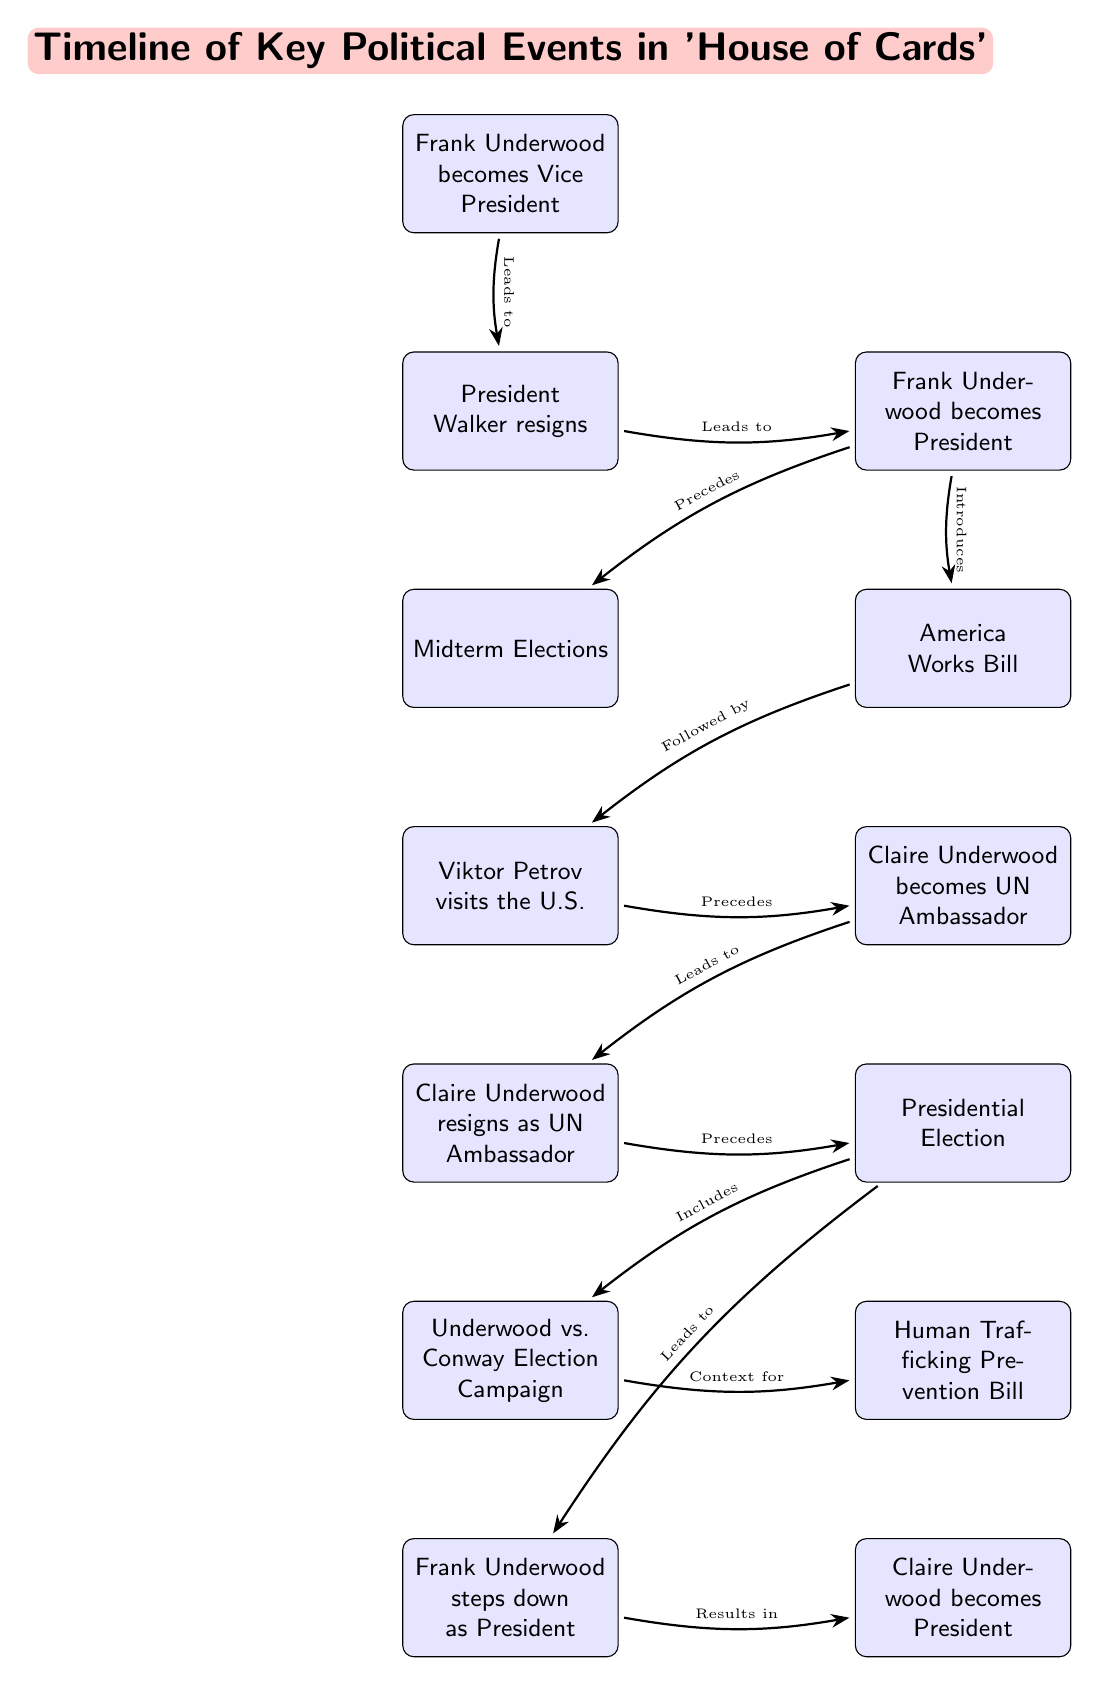What year did Frank Underwood become Vice President? The diagram states that Frank Underwood became Vice President in the year listed next to his event node, which is 2013.
Answer: 2013 What is the event that immediately precedes the Presidential Election? The diagram shows that Claire Underwood's resignation as UN Ambassador directly precedes the Presidential Election event in the timeline.
Answer: Claire Underwood resigns as UN Ambassador How many significant political events are mentioned in the diagram? By counting the individual event nodes in the diagram, there are nine significant political events listed.
Answer: 9 What event follows the introduction of the America Works Bill? The diagram indicates that the visit by Viktor Petrov follows the introduction of the America Works Bill in the timeline.
Answer: Viktor Petrov visits the U.S Which character becomes President after Frank Underwood steps down? The diagram illustrates that Claire Underwood becomes President after Frank Underwood steps down, as this is indicated in the event nodes and the connection path.
Answer: Claire Underwood What is the relationship between the Underwood vs. Conway Election Campaign and the Presidential Election? The diagram shows that the Underwood vs. Conway Election Campaign is included within the context of the Presidential Election event.
Answer: Included in What event leads to Frank Underwood stepping down as President? According to the diagram, the Presidential Election event leads to Frank Underwood stepping down as President, as shown by the connecting arrow that establishes this relationship.
Answer: Presidential Election What action follows Claire Underwood's appointment as UN Ambassador? The diagram reveals that after Claire Underwood becomes UN Ambassador, her resignation from that position is the next event that follows.
Answer: Claire Underwood resigns as UN Ambassador What bill is linked to the context of the Underwood vs. Conway Election Campaign? The diagram specifies that the Human Trafficking Prevention Bill is the event that relates to the context of the Underwood vs. Conway Election Campaign.
Answer: Human Trafficking Prevention Bill 